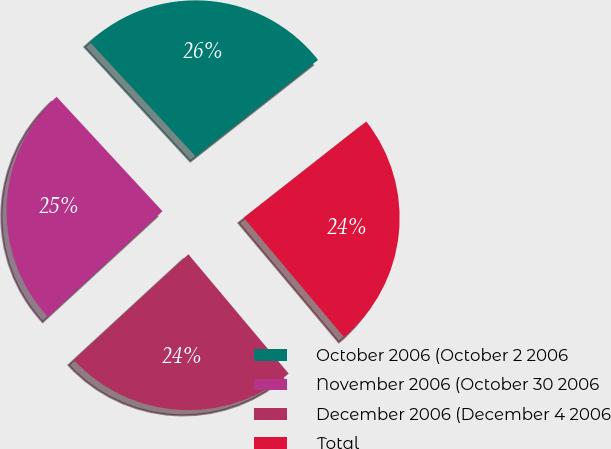Convert chart. <chart><loc_0><loc_0><loc_500><loc_500><pie_chart><fcel>October 2006 (October 2 2006<fcel>November 2006 (October 30 2006<fcel>December 2006 (December 4 2006<fcel>Total<nl><fcel>26.28%<fcel>24.97%<fcel>24.27%<fcel>24.47%<nl></chart> 